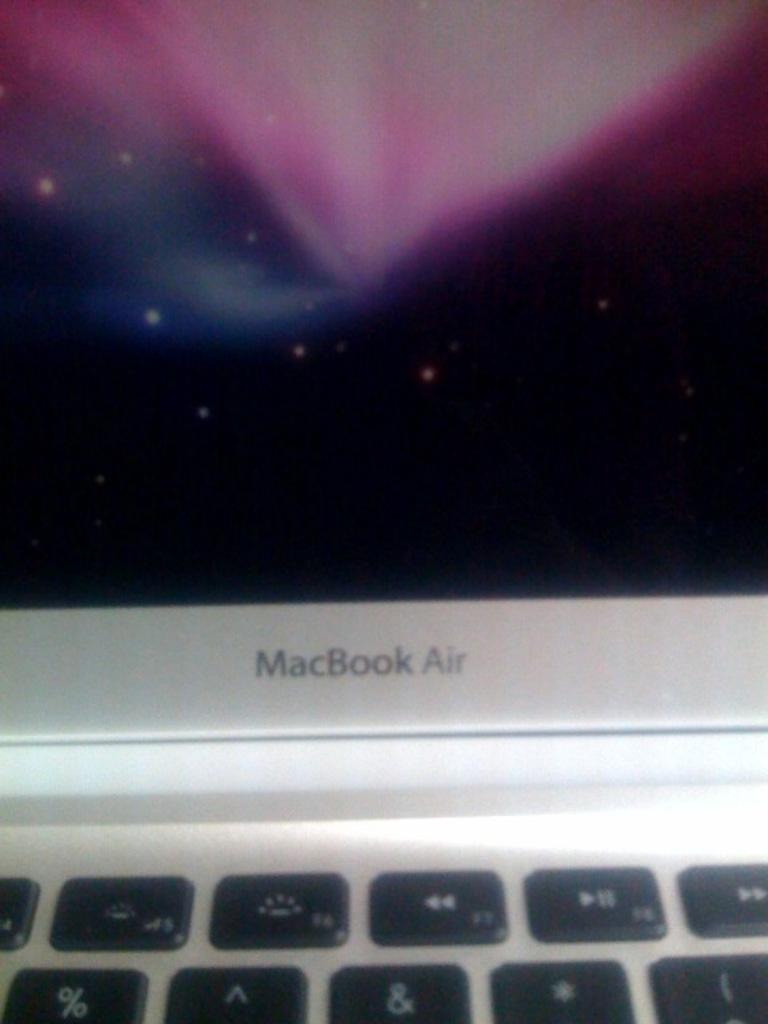What kind of laptop is shown?
Your answer should be compact. Macbook air. 